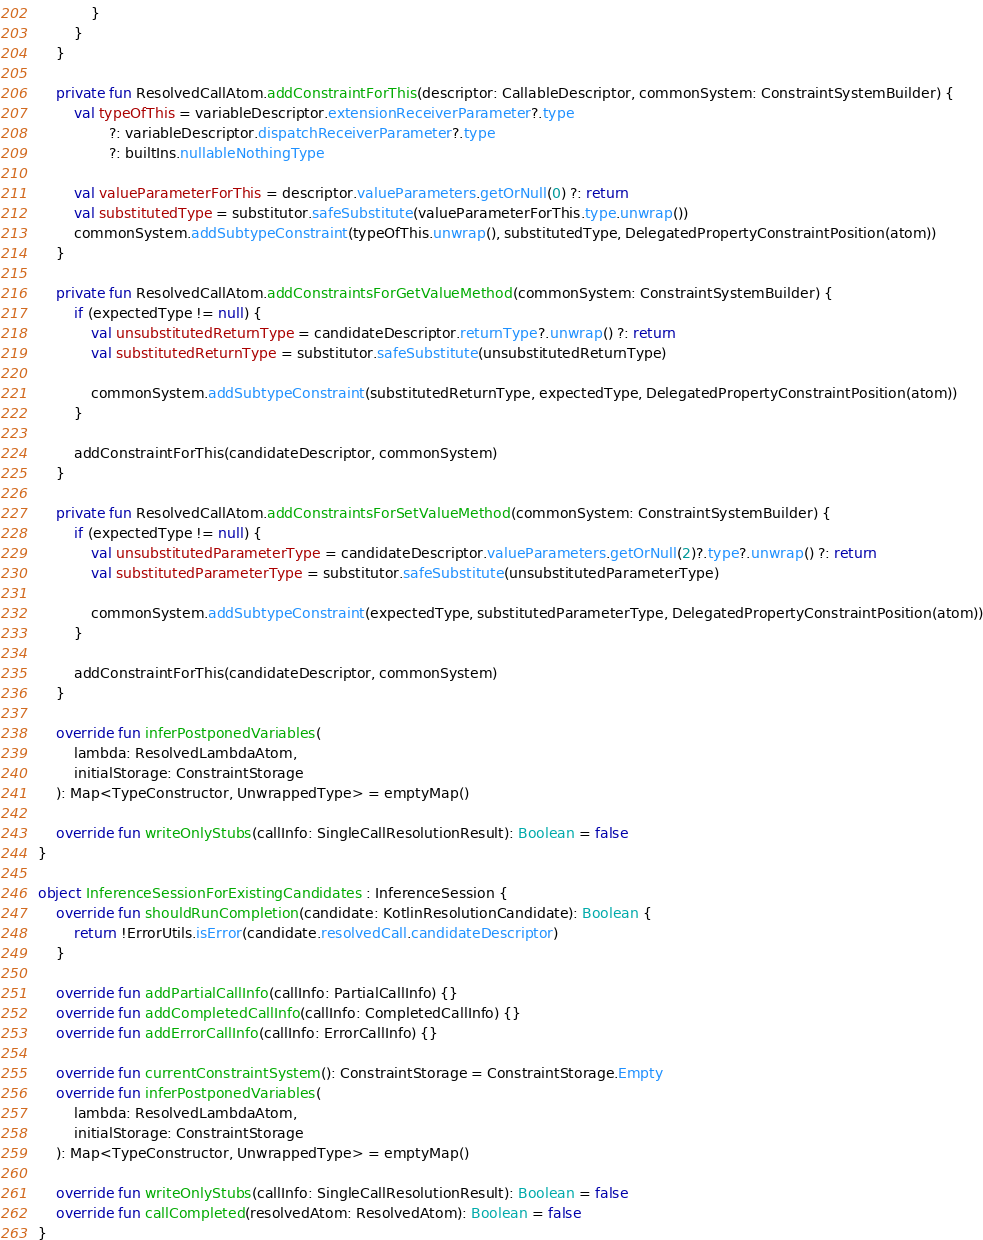<code> <loc_0><loc_0><loc_500><loc_500><_Kotlin_>            }
        }
    }

    private fun ResolvedCallAtom.addConstraintForThis(descriptor: CallableDescriptor, commonSystem: ConstraintSystemBuilder) {
        val typeOfThis = variableDescriptor.extensionReceiverParameter?.type
                ?: variableDescriptor.dispatchReceiverParameter?.type
                ?: builtIns.nullableNothingType

        val valueParameterForThis = descriptor.valueParameters.getOrNull(0) ?: return
        val substitutedType = substitutor.safeSubstitute(valueParameterForThis.type.unwrap())
        commonSystem.addSubtypeConstraint(typeOfThis.unwrap(), substitutedType, DelegatedPropertyConstraintPosition(atom))
    }

    private fun ResolvedCallAtom.addConstraintsForGetValueMethod(commonSystem: ConstraintSystemBuilder) {
        if (expectedType != null) {
            val unsubstitutedReturnType = candidateDescriptor.returnType?.unwrap() ?: return
            val substitutedReturnType = substitutor.safeSubstitute(unsubstitutedReturnType)

            commonSystem.addSubtypeConstraint(substitutedReturnType, expectedType, DelegatedPropertyConstraintPosition(atom))
        }

        addConstraintForThis(candidateDescriptor, commonSystem)
    }

    private fun ResolvedCallAtom.addConstraintsForSetValueMethod(commonSystem: ConstraintSystemBuilder) {
        if (expectedType != null) {
            val unsubstitutedParameterType = candidateDescriptor.valueParameters.getOrNull(2)?.type?.unwrap() ?: return
            val substitutedParameterType = substitutor.safeSubstitute(unsubstitutedParameterType)

            commonSystem.addSubtypeConstraint(expectedType, substitutedParameterType, DelegatedPropertyConstraintPosition(atom))
        }

        addConstraintForThis(candidateDescriptor, commonSystem)
    }

    override fun inferPostponedVariables(
        lambda: ResolvedLambdaAtom,
        initialStorage: ConstraintStorage
    ): Map<TypeConstructor, UnwrappedType> = emptyMap()

    override fun writeOnlyStubs(callInfo: SingleCallResolutionResult): Boolean = false
}

object InferenceSessionForExistingCandidates : InferenceSession {
    override fun shouldRunCompletion(candidate: KotlinResolutionCandidate): Boolean {
        return !ErrorUtils.isError(candidate.resolvedCall.candidateDescriptor)
    }

    override fun addPartialCallInfo(callInfo: PartialCallInfo) {}
    override fun addCompletedCallInfo(callInfo: CompletedCallInfo) {}
    override fun addErrorCallInfo(callInfo: ErrorCallInfo) {}

    override fun currentConstraintSystem(): ConstraintStorage = ConstraintStorage.Empty
    override fun inferPostponedVariables(
        lambda: ResolvedLambdaAtom,
        initialStorage: ConstraintStorage
    ): Map<TypeConstructor, UnwrappedType> = emptyMap()

    override fun writeOnlyStubs(callInfo: SingleCallResolutionResult): Boolean = false
    override fun callCompleted(resolvedAtom: ResolvedAtom): Boolean = false
}
</code> 